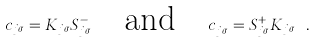Convert formula to latex. <formula><loc_0><loc_0><loc_500><loc_500>c _ { j \sigma } = K _ { j \sigma } S _ { j \sigma } ^ { - } \quad \text {and} \quad c _ { j \sigma } ^ { \dagger } = S _ { j \sigma } ^ { + } K _ { j \sigma } \ .</formula> 